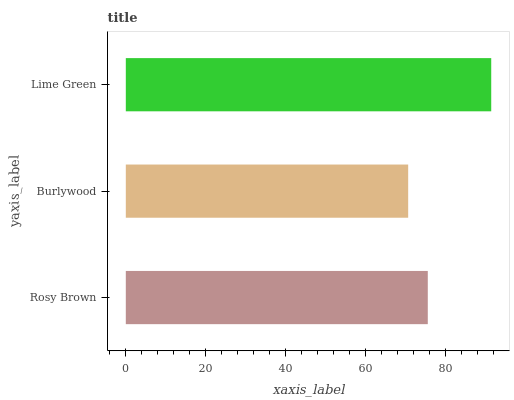Is Burlywood the minimum?
Answer yes or no. Yes. Is Lime Green the maximum?
Answer yes or no. Yes. Is Lime Green the minimum?
Answer yes or no. No. Is Burlywood the maximum?
Answer yes or no. No. Is Lime Green greater than Burlywood?
Answer yes or no. Yes. Is Burlywood less than Lime Green?
Answer yes or no. Yes. Is Burlywood greater than Lime Green?
Answer yes or no. No. Is Lime Green less than Burlywood?
Answer yes or no. No. Is Rosy Brown the high median?
Answer yes or no. Yes. Is Rosy Brown the low median?
Answer yes or no. Yes. Is Lime Green the high median?
Answer yes or no. No. Is Burlywood the low median?
Answer yes or no. No. 